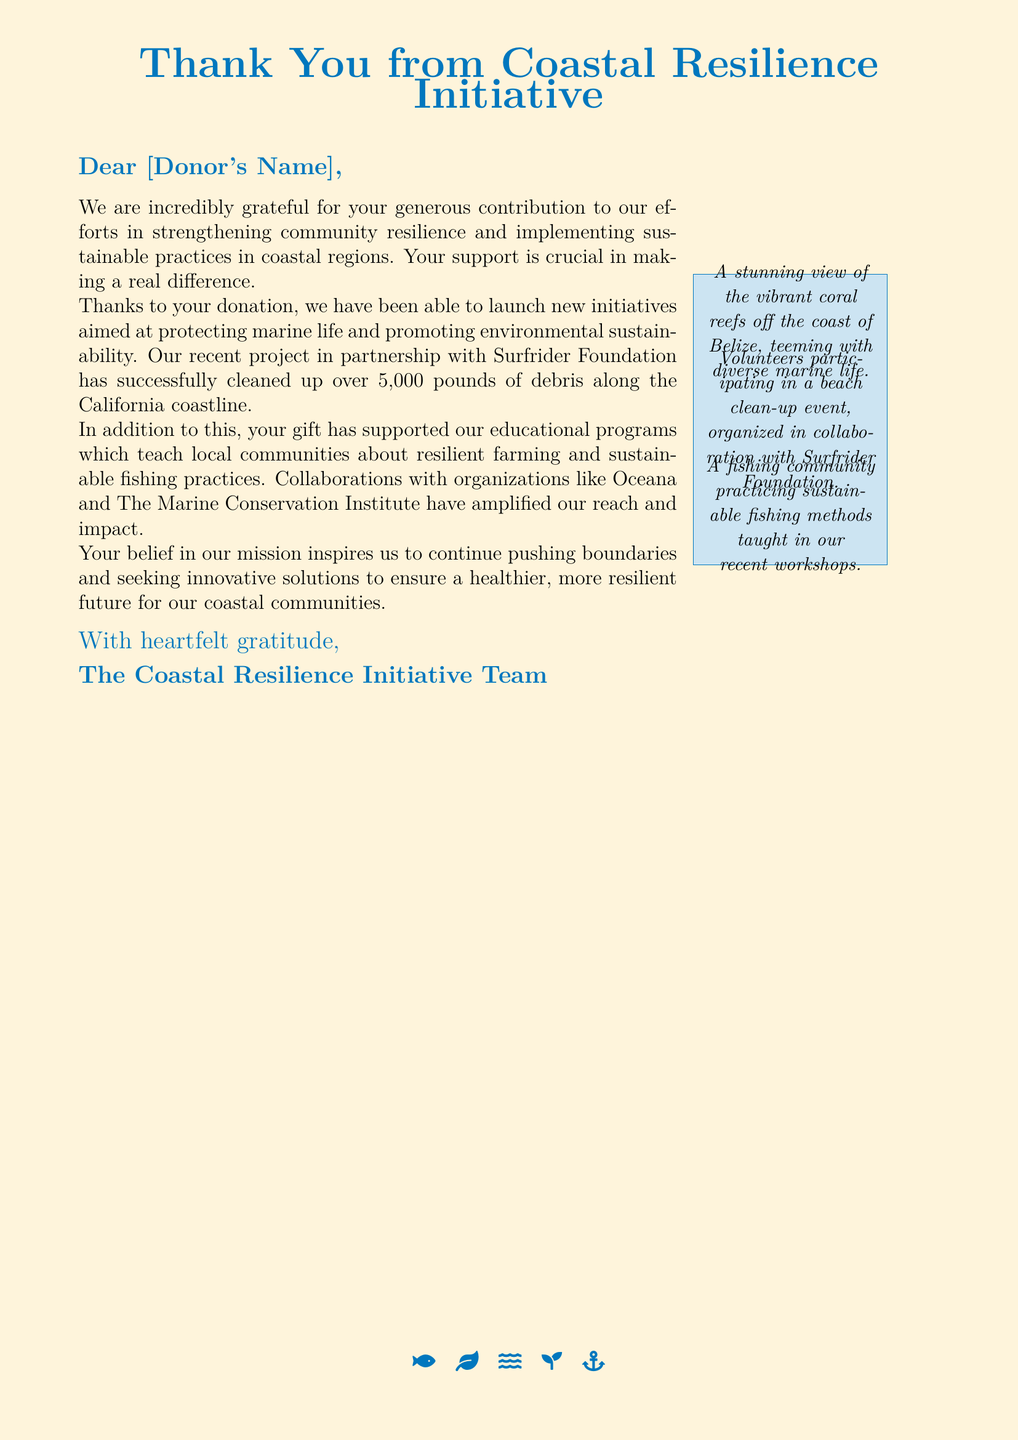What is the name of the initiative? The greeting card states that the name of the initiative is Coastal Resilience Initiative.
Answer: Coastal Resilience Initiative Who was the letter addressed to? The document template indicates that the letter is addressed to "[Donor's Name]."
Answer: [Donor's Name] How much debris was cleaned up along the California coastline? The document specifies that over 5,000 pounds of debris were cleaned up.
Answer: 5,000 pounds Which foundation was mentioned in collaboration for the cleanup? The text refers to the Surfrider Foundation as a partner for the cleanup efforts.
Answer: Surfrider Foundation What does the initiative promote in coastal regions? The initiative promotes environmental sustainability and resilience in coastal regions.
Answer: Environmental sustainability What marine life activity is mentioned in the card? The card references protecting marine life as part of the initiative's goals.
Answer: Protecting marine life What type of practices does the initiative teach to local communities? The document mentions resilient farming and sustainable fishing practices being taught to local communities.
Answer: Resilient farming and sustainable fishing Which organizations are involved in collaboration according to the card? The card lists Oceana and The Marine Conservation Institute as collaborating organizations.
Answer: Oceana and The Marine Conservation Institute 